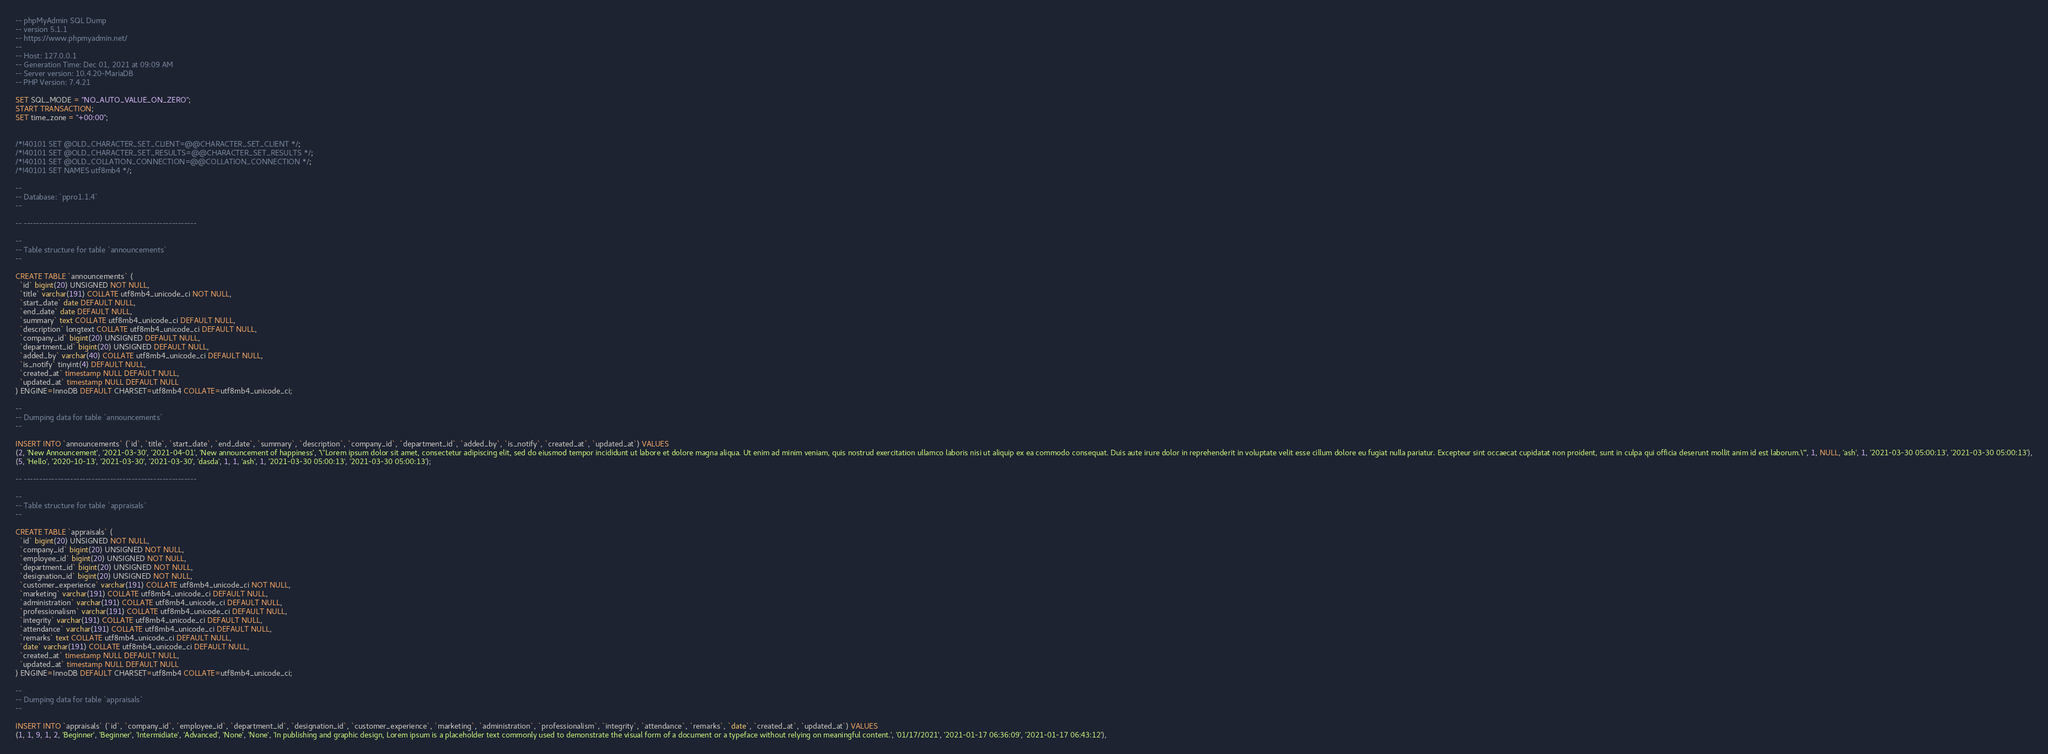Convert code to text. <code><loc_0><loc_0><loc_500><loc_500><_SQL_>-- phpMyAdmin SQL Dump
-- version 5.1.1
-- https://www.phpmyadmin.net/
--
-- Host: 127.0.0.1
-- Generation Time: Dec 01, 2021 at 09:09 AM
-- Server version: 10.4.20-MariaDB
-- PHP Version: 7.4.21

SET SQL_MODE = "NO_AUTO_VALUE_ON_ZERO";
START TRANSACTION;
SET time_zone = "+00:00";


/*!40101 SET @OLD_CHARACTER_SET_CLIENT=@@CHARACTER_SET_CLIENT */;
/*!40101 SET @OLD_CHARACTER_SET_RESULTS=@@CHARACTER_SET_RESULTS */;
/*!40101 SET @OLD_COLLATION_CONNECTION=@@COLLATION_CONNECTION */;
/*!40101 SET NAMES utf8mb4 */;

--
-- Database: `ppro1.1.4`
--

-- --------------------------------------------------------

--
-- Table structure for table `announcements`
--

CREATE TABLE `announcements` (
  `id` bigint(20) UNSIGNED NOT NULL,
  `title` varchar(191) COLLATE utf8mb4_unicode_ci NOT NULL,
  `start_date` date DEFAULT NULL,
  `end_date` date DEFAULT NULL,
  `summary` text COLLATE utf8mb4_unicode_ci DEFAULT NULL,
  `description` longtext COLLATE utf8mb4_unicode_ci DEFAULT NULL,
  `company_id` bigint(20) UNSIGNED DEFAULT NULL,
  `department_id` bigint(20) UNSIGNED DEFAULT NULL,
  `added_by` varchar(40) COLLATE utf8mb4_unicode_ci DEFAULT NULL,
  `is_notify` tinyint(4) DEFAULT NULL,
  `created_at` timestamp NULL DEFAULT NULL,
  `updated_at` timestamp NULL DEFAULT NULL
) ENGINE=InnoDB DEFAULT CHARSET=utf8mb4 COLLATE=utf8mb4_unicode_ci;

--
-- Dumping data for table `announcements`
--

INSERT INTO `announcements` (`id`, `title`, `start_date`, `end_date`, `summary`, `description`, `company_id`, `department_id`, `added_by`, `is_notify`, `created_at`, `updated_at`) VALUES
(2, 'New Announcement', '2021-03-30', '2021-04-01', 'New announcement of happiness', '\"Lorem ipsum dolor sit amet, consectetur adipiscing elit, sed do eiusmod tempor incididunt ut labore et dolore magna aliqua. Ut enim ad minim veniam, quis nostrud exercitation ullamco laboris nisi ut aliquip ex ea commodo consequat. Duis aute irure dolor in reprehenderit in voluptate velit esse cillum dolore eu fugiat nulla pariatur. Excepteur sint occaecat cupidatat non proident, sunt in culpa qui officia deserunt mollit anim id est laborum.\"', 1, NULL, 'ash', 1, '2021-03-30 05:00:13', '2021-03-30 05:00:13'),
(5, 'Hello', '2020-10-13', '2021-03-30', '2021-03-30', 'dasda', 1, 1, 'ash', 1, '2021-03-30 05:00:13', '2021-03-30 05:00:13');

-- --------------------------------------------------------

--
-- Table structure for table `appraisals`
--

CREATE TABLE `appraisals` (
  `id` bigint(20) UNSIGNED NOT NULL,
  `company_id` bigint(20) UNSIGNED NOT NULL,
  `employee_id` bigint(20) UNSIGNED NOT NULL,
  `department_id` bigint(20) UNSIGNED NOT NULL,
  `designation_id` bigint(20) UNSIGNED NOT NULL,
  `customer_experience` varchar(191) COLLATE utf8mb4_unicode_ci NOT NULL,
  `marketing` varchar(191) COLLATE utf8mb4_unicode_ci DEFAULT NULL,
  `administration` varchar(191) COLLATE utf8mb4_unicode_ci DEFAULT NULL,
  `professionalism` varchar(191) COLLATE utf8mb4_unicode_ci DEFAULT NULL,
  `integrity` varchar(191) COLLATE utf8mb4_unicode_ci DEFAULT NULL,
  `attendance` varchar(191) COLLATE utf8mb4_unicode_ci DEFAULT NULL,
  `remarks` text COLLATE utf8mb4_unicode_ci DEFAULT NULL,
  `date` varchar(191) COLLATE utf8mb4_unicode_ci DEFAULT NULL,
  `created_at` timestamp NULL DEFAULT NULL,
  `updated_at` timestamp NULL DEFAULT NULL
) ENGINE=InnoDB DEFAULT CHARSET=utf8mb4 COLLATE=utf8mb4_unicode_ci;

--
-- Dumping data for table `appraisals`
--

INSERT INTO `appraisals` (`id`, `company_id`, `employee_id`, `department_id`, `designation_id`, `customer_experience`, `marketing`, `administration`, `professionalism`, `integrity`, `attendance`, `remarks`, `date`, `created_at`, `updated_at`) VALUES
(1, 1, 9, 1, 2, 'Beginner', 'Beginner', 'Intermidiate', 'Advanced', 'None', 'None', 'In publishing and graphic design, Lorem ipsum is a placeholder text commonly used to demonstrate the visual form of a document or a typeface without relying on meaningful content.', '01/17/2021', '2021-01-17 06:36:09', '2021-01-17 06:43:12'),</code> 